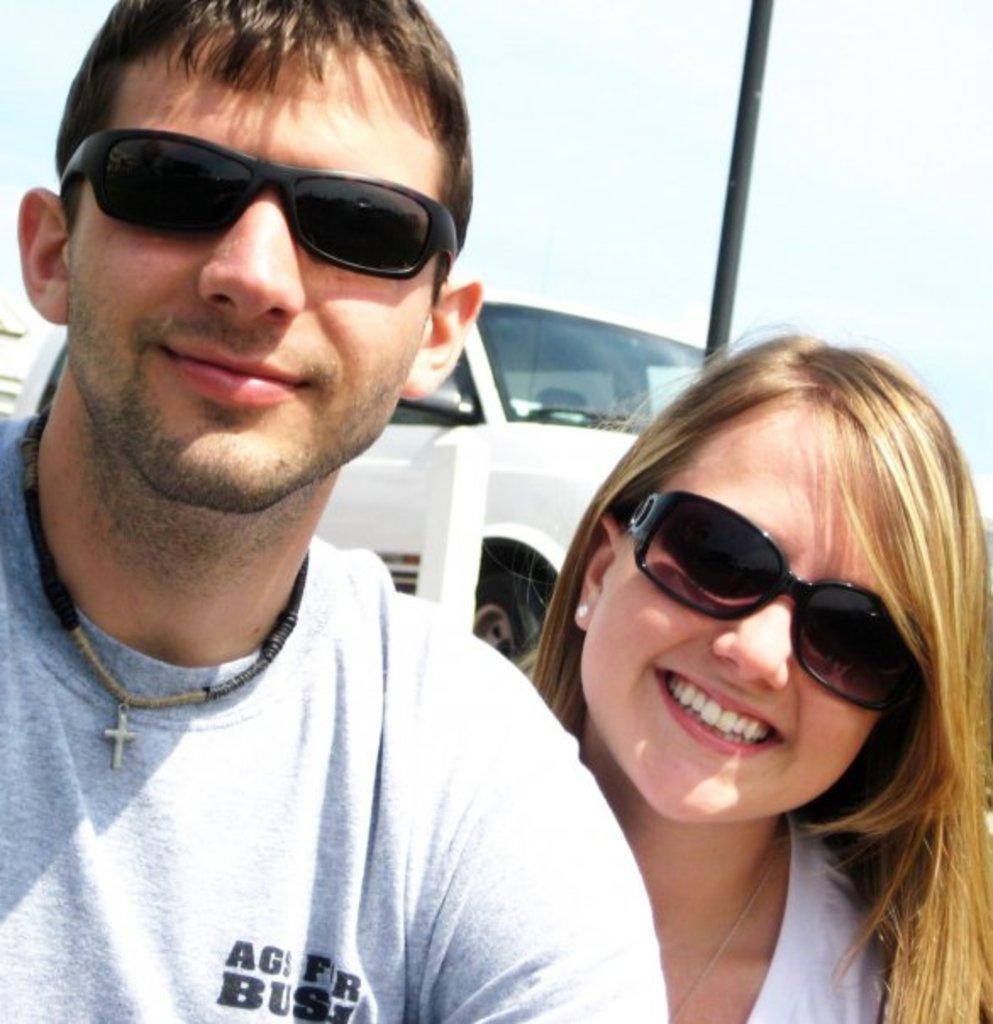Could you give a brief overview of what you see in this image? In this picture we can see a man and woman, she wore spectacles, and they are smiling, in the background we can see a vehicle and a pole. 